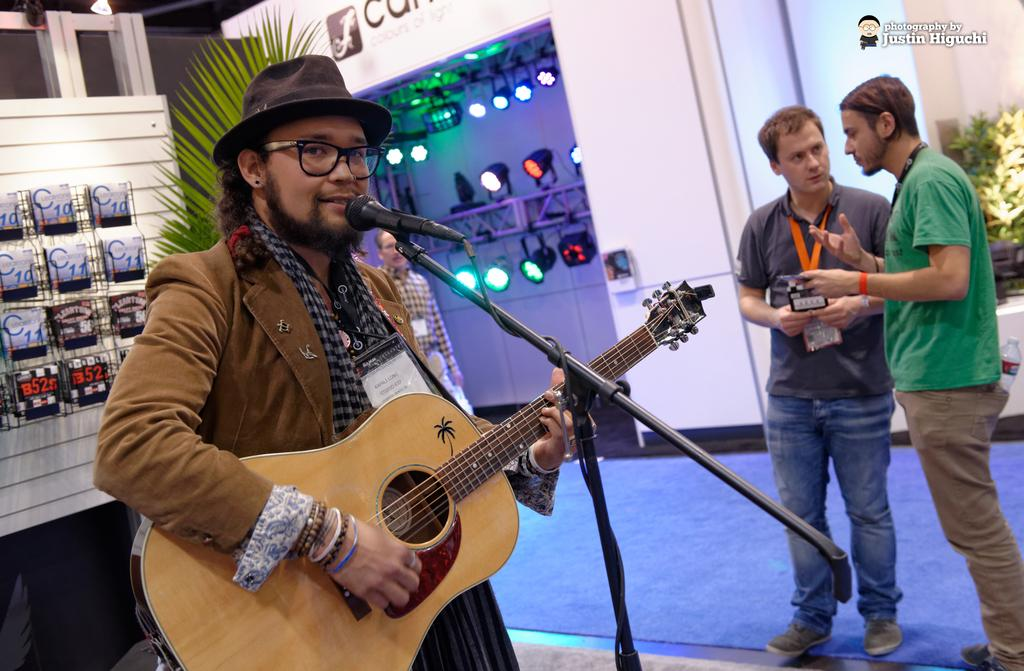What is the man in the image doing? The man is standing and playing guitar in the image. Is the man singing while playing the guitar? Yes, the man is singing with the help of a microphone. Are there any other people in the image? Yes, there are two men standing on the side in the image. What are the two men doing? The two men are speaking to each other. What invention is the man using to play the guitar in the image? The man is not using any invention to play the guitar in the image; he is simply playing it. Is there a crime being committed in the image? There is no indication of a crime being committed in the image. 